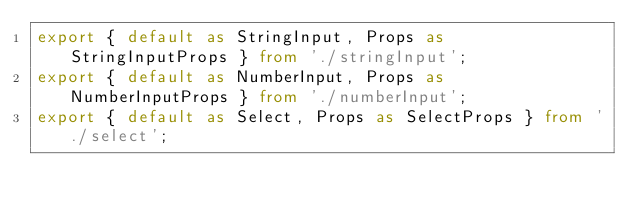Convert code to text. <code><loc_0><loc_0><loc_500><loc_500><_TypeScript_>export { default as StringInput, Props as StringInputProps } from './stringInput';
export { default as NumberInput, Props as NumberInputProps } from './numberInput';
export { default as Select, Props as SelectProps } from './select';
</code> 